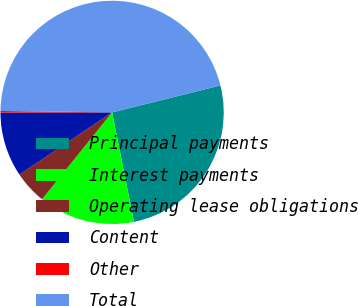<chart> <loc_0><loc_0><loc_500><loc_500><pie_chart><fcel>Principal payments<fcel>Interest payments<fcel>Operating lease obligations<fcel>Content<fcel>Other<fcel>Total<nl><fcel>25.74%<fcel>13.94%<fcel>4.8%<fcel>9.37%<fcel>0.23%<fcel>45.93%<nl></chart> 